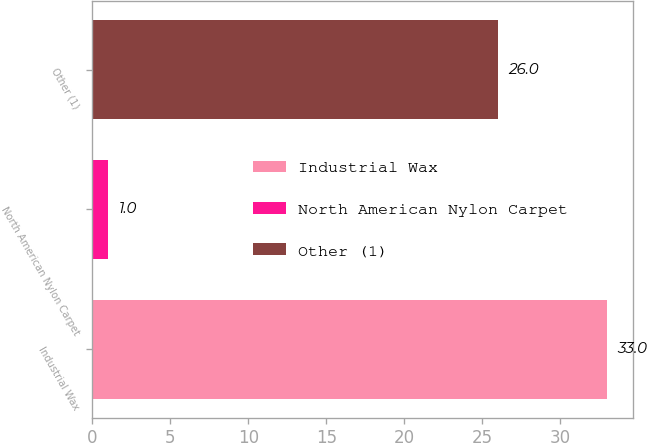Convert chart. <chart><loc_0><loc_0><loc_500><loc_500><bar_chart><fcel>Industrial Wax<fcel>North American Nylon Carpet<fcel>Other (1)<nl><fcel>33<fcel>1<fcel>26<nl></chart> 